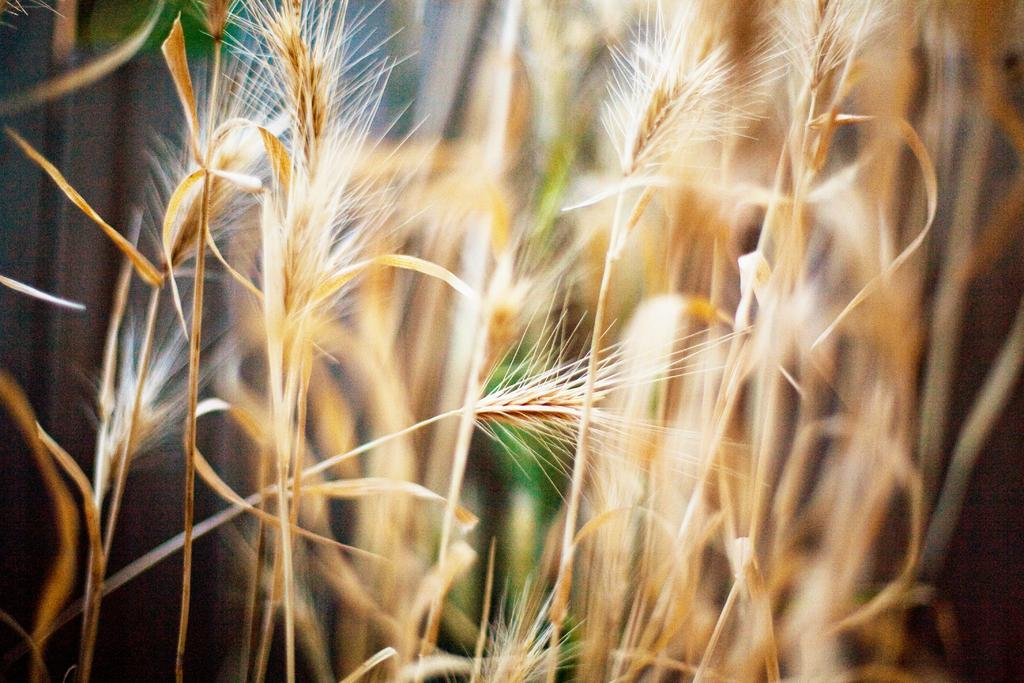What type of vegetation is present in the image? There is dried grass in the image. Can you describe the background of the image? The background of the image is blurry. How many goldfish can be seen swimming in the dried grass in the image? There are no goldfish present in the image; it features dried grass and a blurry background. What type of cork is used to hold the bee in place in the image? There is no bee or cork present in the image. 